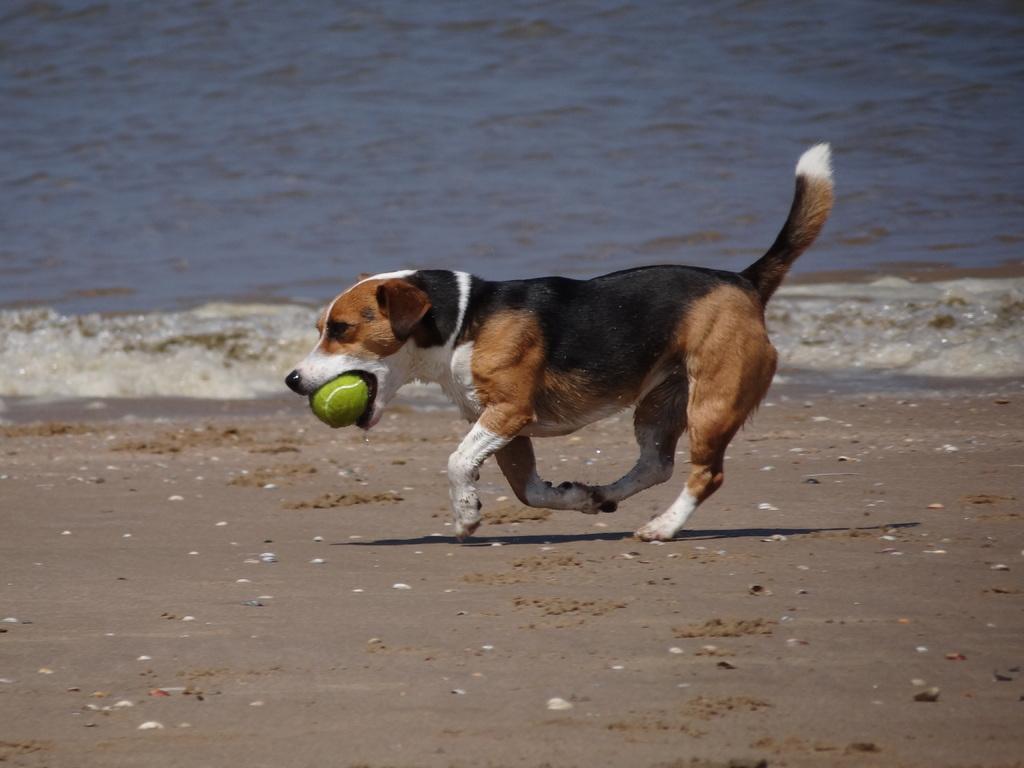Could you give a brief overview of what you see in this image? In this image, we can see a dog running, the dog is holding a ball in the mouth, in the background we can see water. 